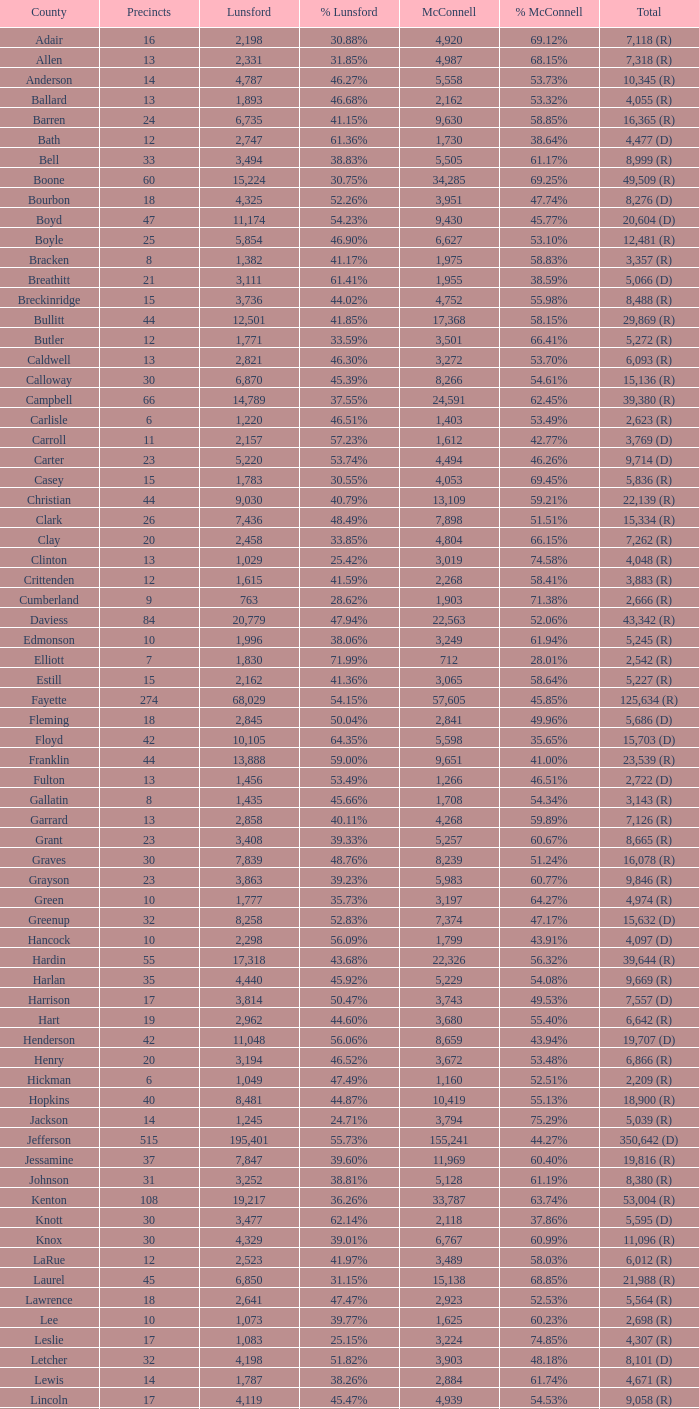What is the overall sum of lunsford votes when they account for 33.85% of the votes? 1.0. 